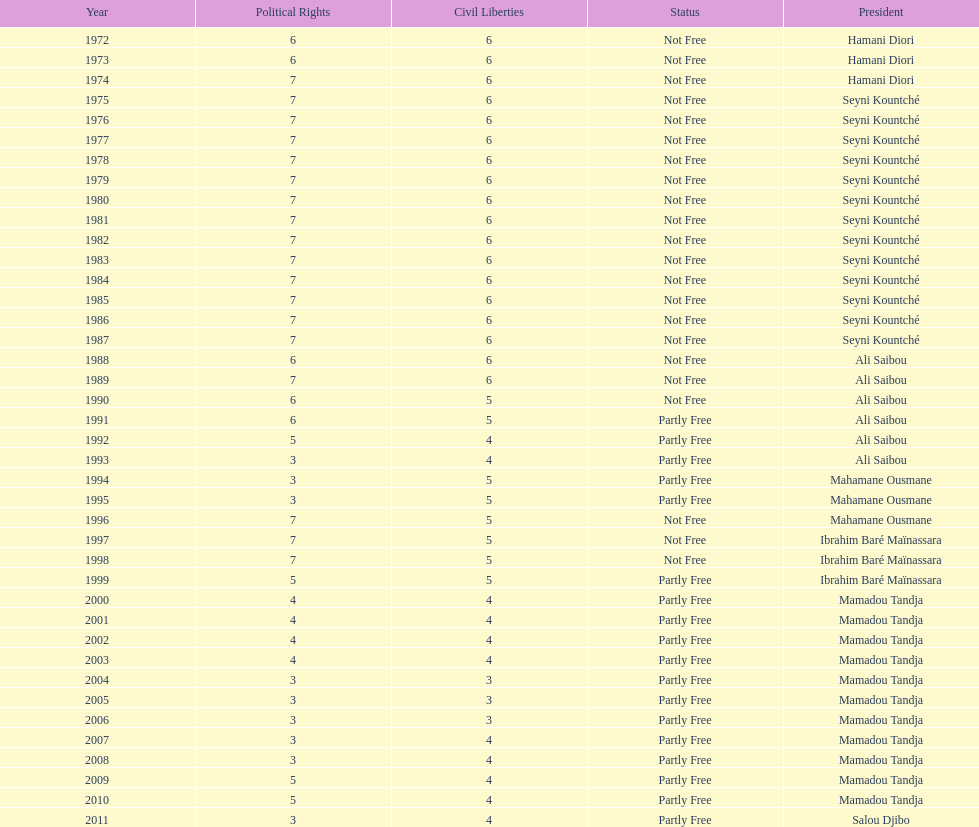Who is the next president listed after hamani diori in the year 1974? Seyni Kountché. 